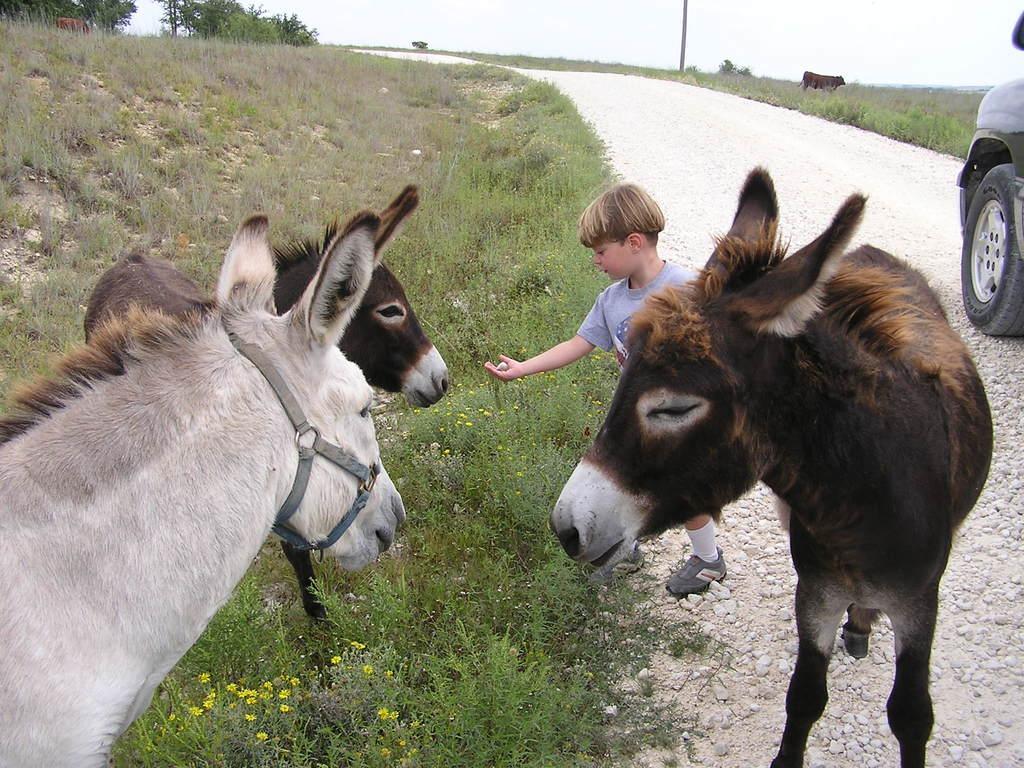Please provide a concise description of this image. In this picture there are donkeys on the right and left side of the image and there is a car on the right side of the image and there is a small boy in the center of the image, there is grassland on the left side of the image. 